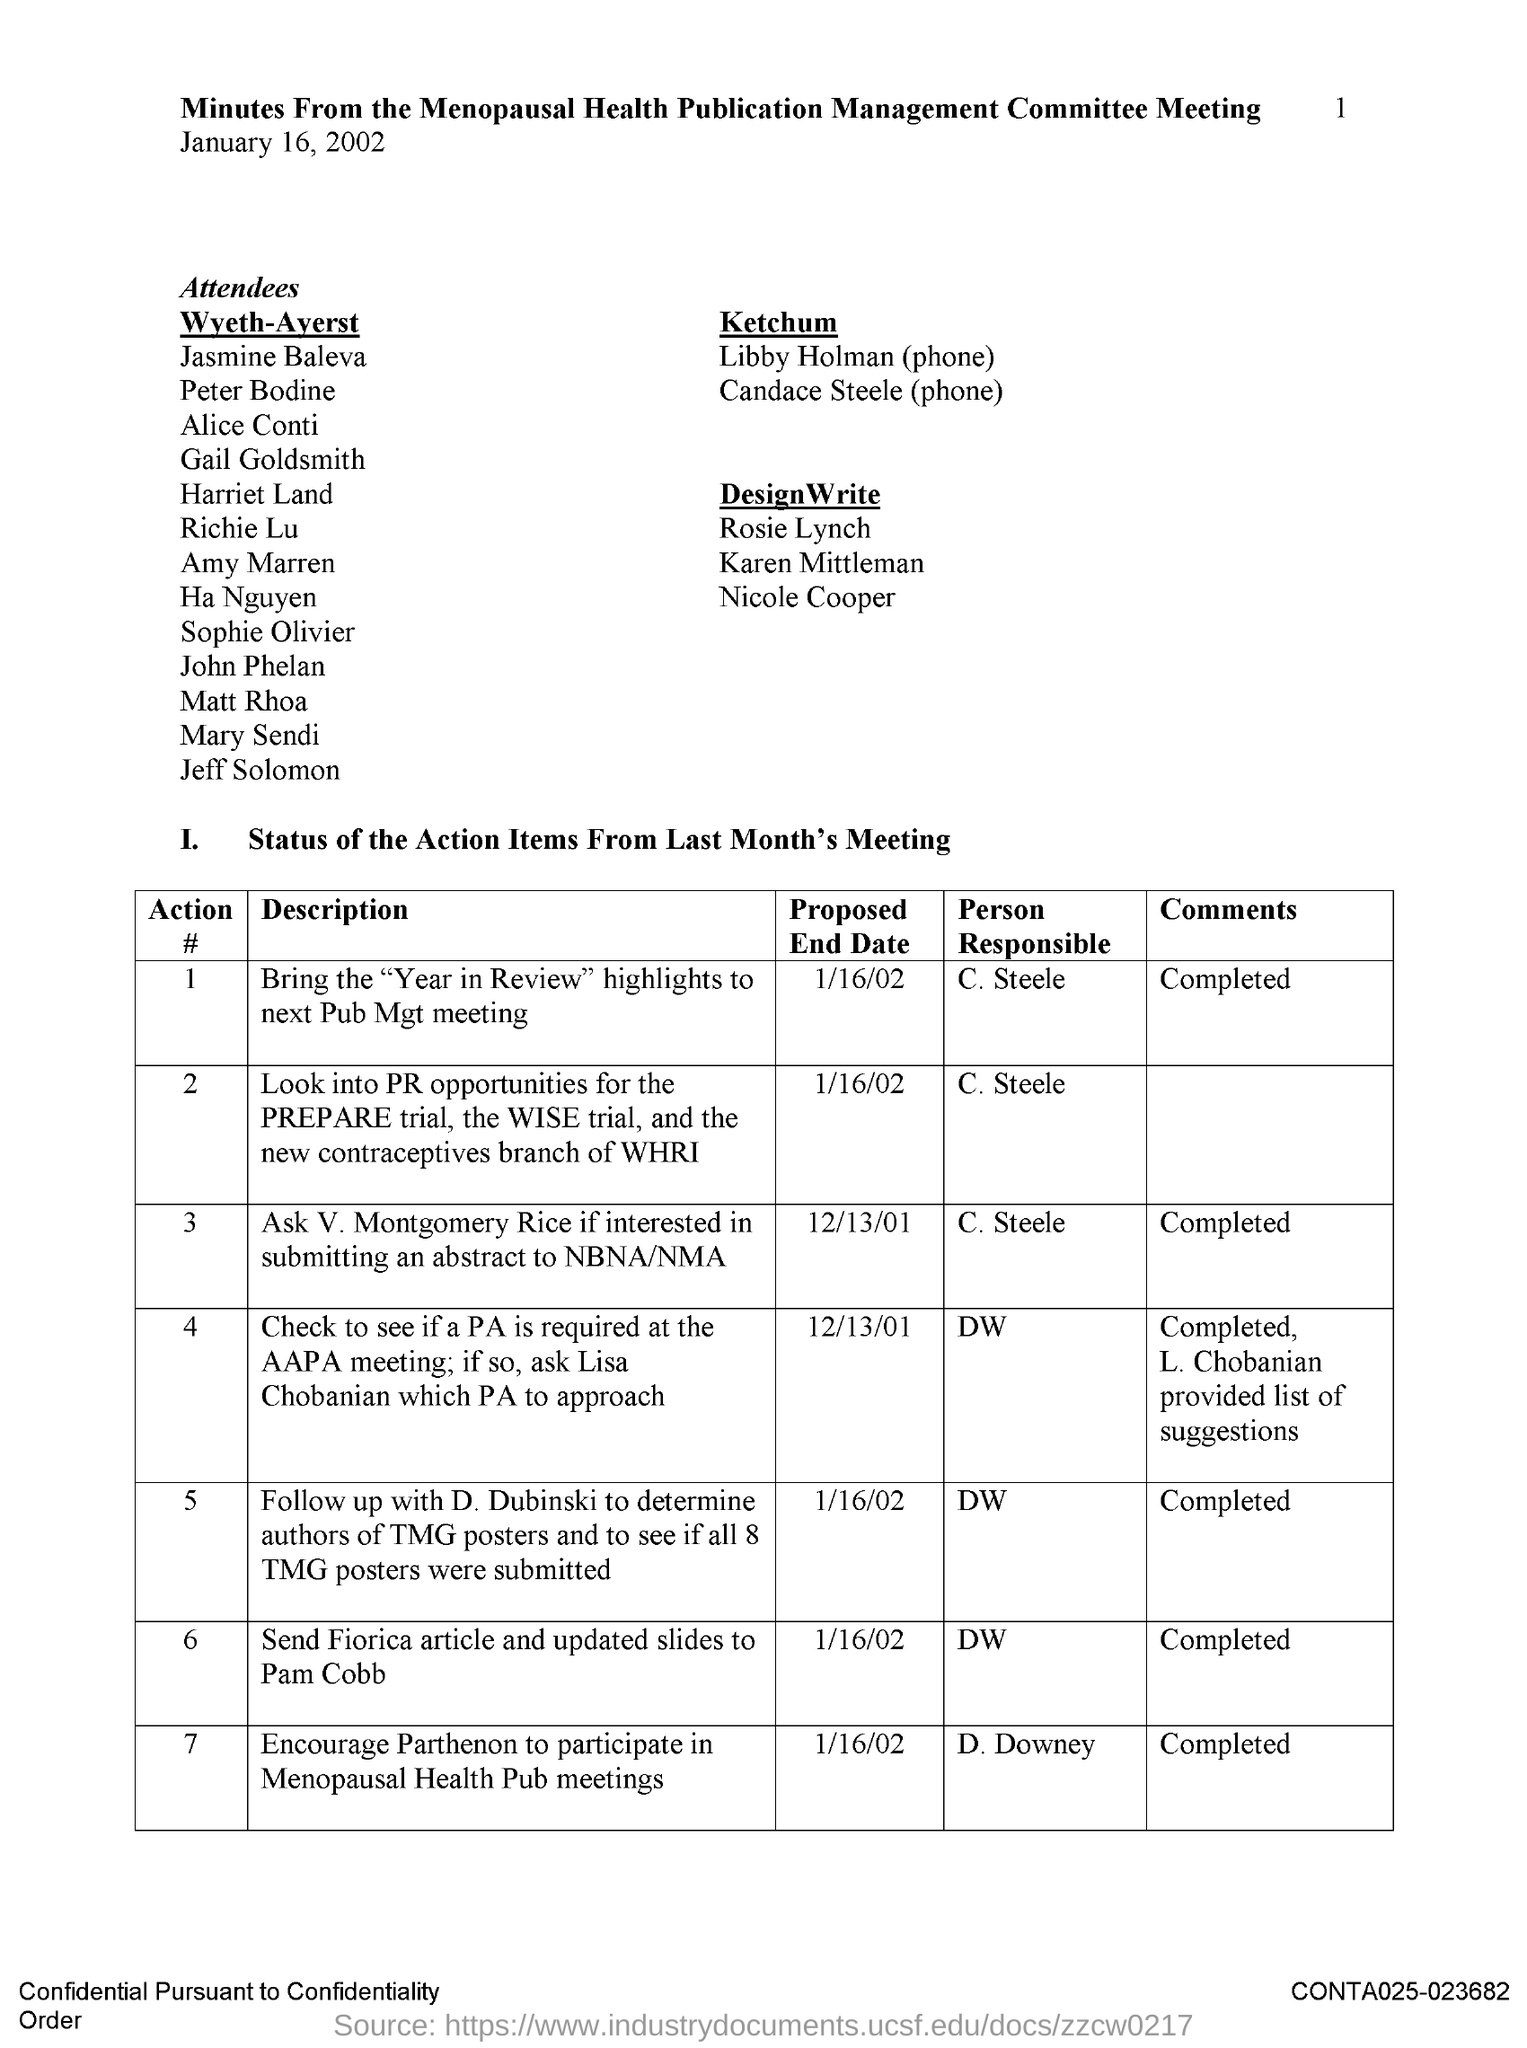Identify some key points in this picture. It is necessary to seek the assistance of V. Montgomery Rice for the purpose of submitting an abstract to NBNA/NMA. C. Steele is responsible for contacting V. Montgomery Rice to determine their interest in doing so. On January 16th, 2002, the proposed end date for sending the article by Fiorica and updated slides to Pam Cobb was established. The person responsible for bringing the Year in Review highlights to the next Pub Mgt meeting is C. Steele. The proposed end date to inquire about submitting an abstract to the National Black Nurses Association (NBNA) or the National Medical Association (NMA) is December 13th, 2001. The person responsible for sending the Fiorica article and updated slides to Pam Cobb is unknown. 